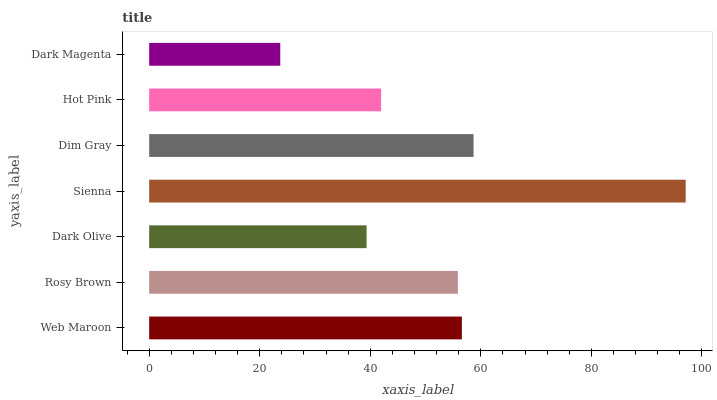Is Dark Magenta the minimum?
Answer yes or no. Yes. Is Sienna the maximum?
Answer yes or no. Yes. Is Rosy Brown the minimum?
Answer yes or no. No. Is Rosy Brown the maximum?
Answer yes or no. No. Is Web Maroon greater than Rosy Brown?
Answer yes or no. Yes. Is Rosy Brown less than Web Maroon?
Answer yes or no. Yes. Is Rosy Brown greater than Web Maroon?
Answer yes or no. No. Is Web Maroon less than Rosy Brown?
Answer yes or no. No. Is Rosy Brown the high median?
Answer yes or no. Yes. Is Rosy Brown the low median?
Answer yes or no. Yes. Is Dim Gray the high median?
Answer yes or no. No. Is Sienna the low median?
Answer yes or no. No. 